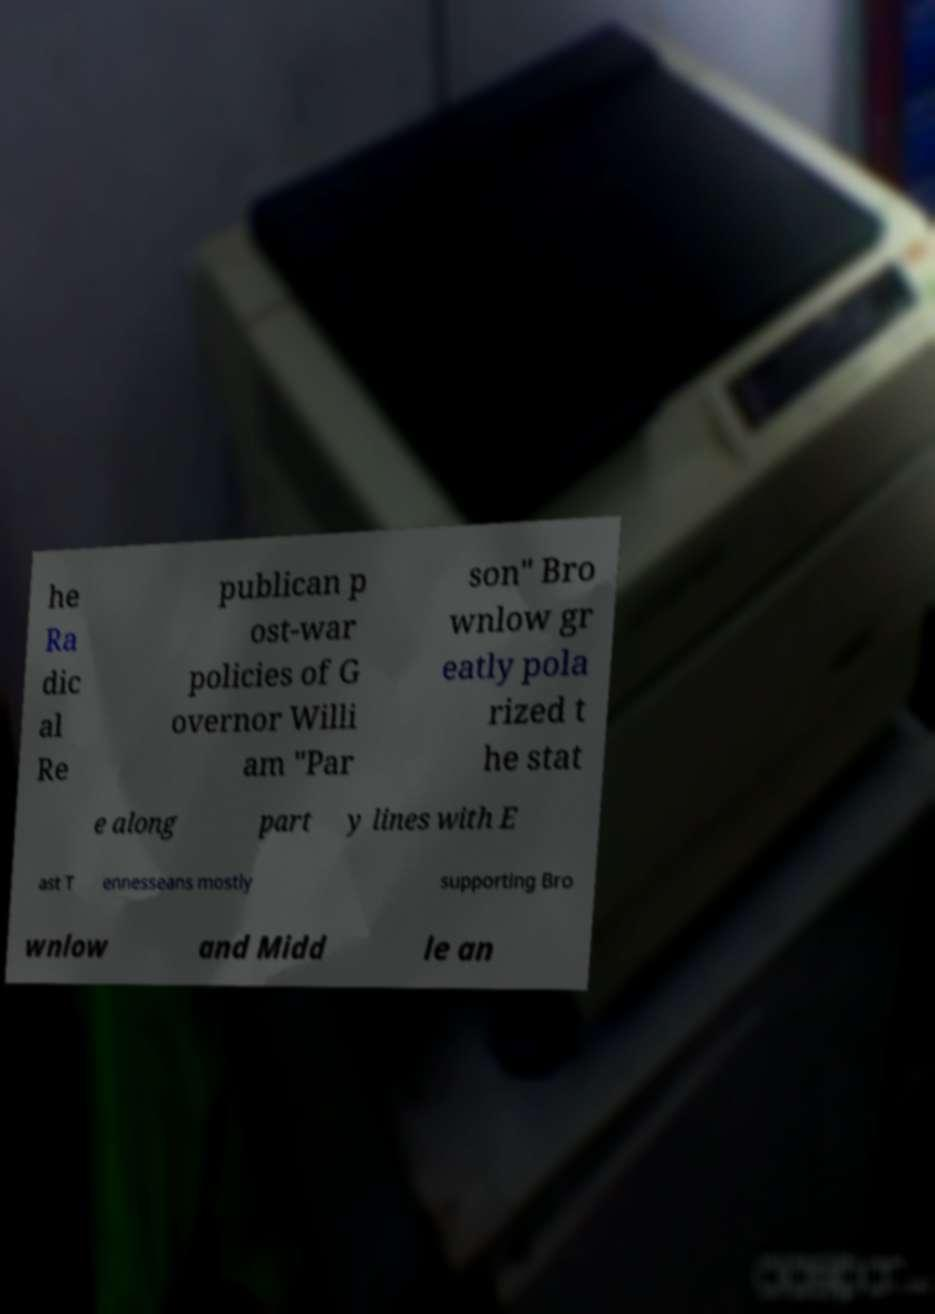Please read and relay the text visible in this image. What does it say? he Ra dic al Re publican p ost-war policies of G overnor Willi am "Par son" Bro wnlow gr eatly pola rized t he stat e along part y lines with E ast T ennesseans mostly supporting Bro wnlow and Midd le an 